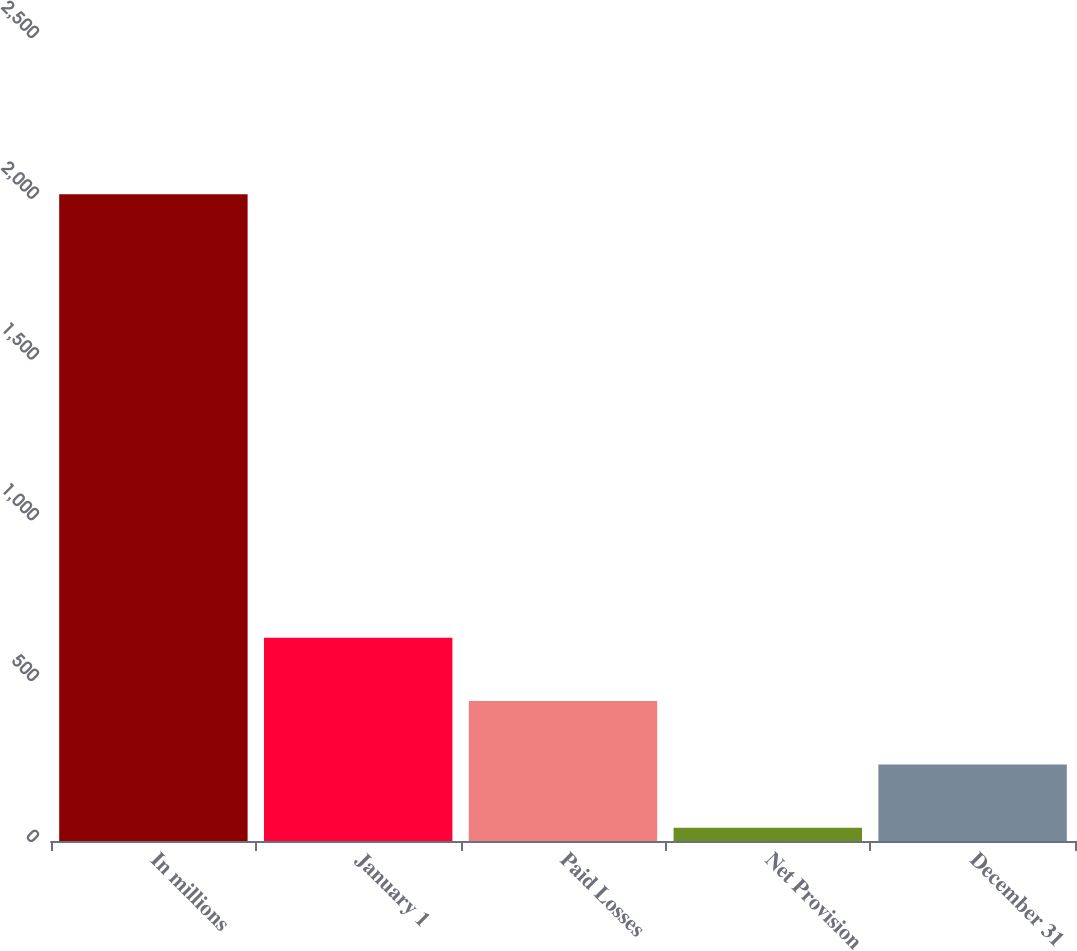<chart> <loc_0><loc_0><loc_500><loc_500><bar_chart><fcel>In millions<fcel>January 1<fcel>Paid Losses<fcel>Net Provision<fcel>December 31<nl><fcel>2011<fcel>632<fcel>435<fcel>41<fcel>238<nl></chart> 